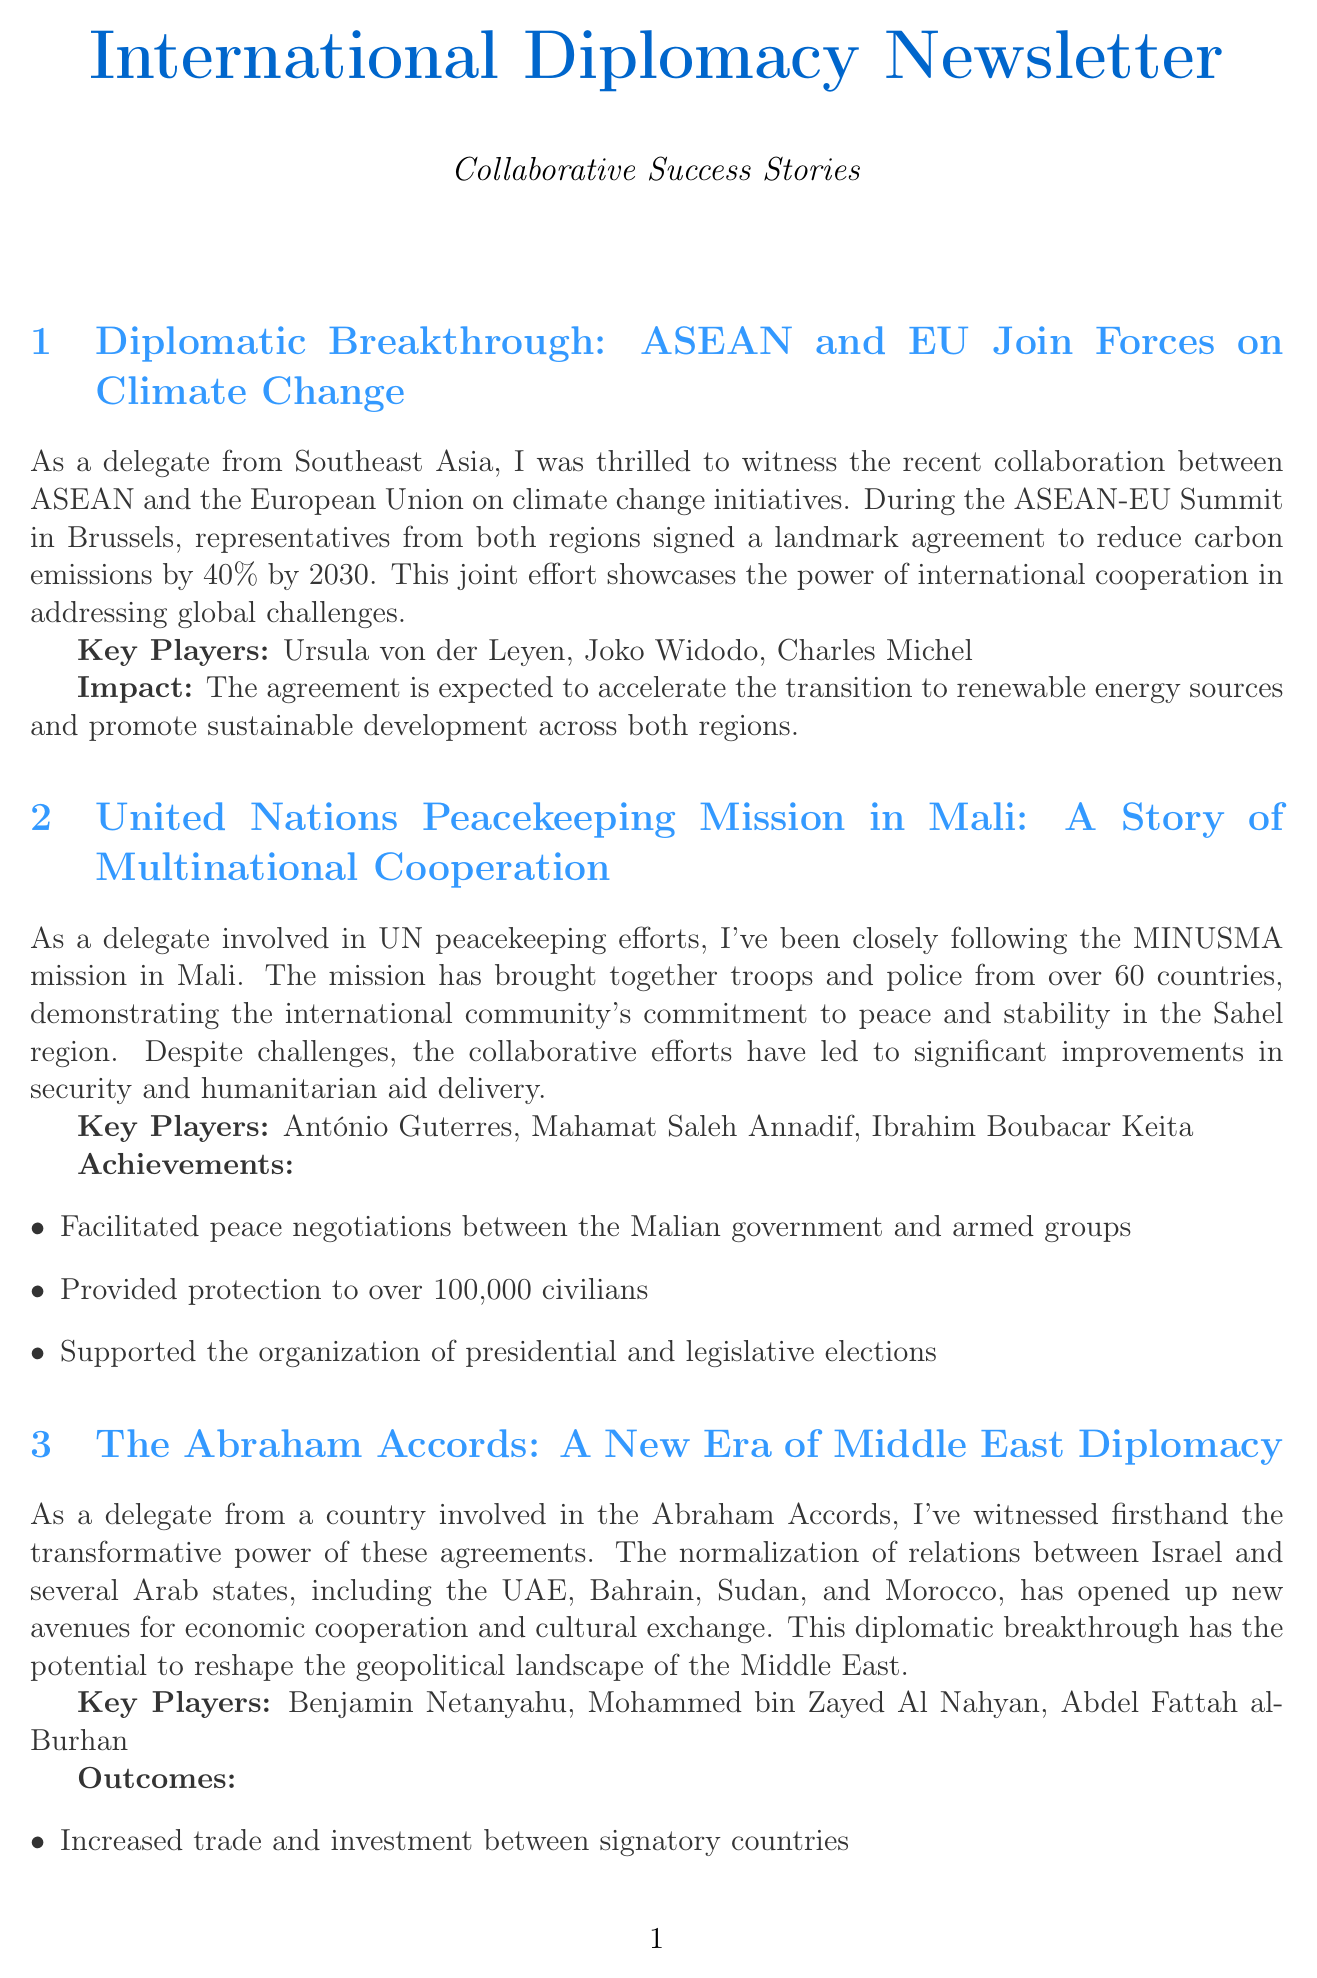What is the carbon emission reduction target signed by ASEAN and the EU? The document states that ASEAN and the EU signed an agreement to reduce carbon emissions by 40% by 2030.
Answer: 40% Who are the three key players in the ASEAN-EU climate change agreement? The key players mentioned in the document are Ursula von der Leyen, Joko Widodo, and Charles Michel.
Answer: Ursula von der Leyen, Joko Widodo, Charles Michel What is the main mission of MINUSMA in Mali? The document describes MINUSMA as a UN peacekeeping mission that demonstrates the international community's commitment to peace and stability in the Sahel region.
Answer: Peace and stability How many countries contribute troops to the MINUSMA mission? The document notes that troops and police from over 60 countries are involved in the MINUSMA mission.
Answer: Over 60 What is one of the outcomes of the Abraham Accords? One outcome mentioned is increased trade and investment between signatory countries.
Answer: Increased trade and investment Which initiative aims to promote equitable access to COVID-19 vaccines? The document highlights the COVAX initiative as the program focused on equitable access to COVID-19 vaccines.
Answer: COVAX initiative How many doses of COVID-19 vaccines were secured for equitable distribution through the COVAX initiative? The document indicates that over 2 billion doses of COVID-19 vaccines were secured for distribution.
Answer: Over 2 billion What collaborative organizations lead the COVAX initiative? The key players leading the COVAX initiative mentioned in the document are Gavi, the WHO, and CEPI.
Answer: Gavi, the WHO, and CEPI 